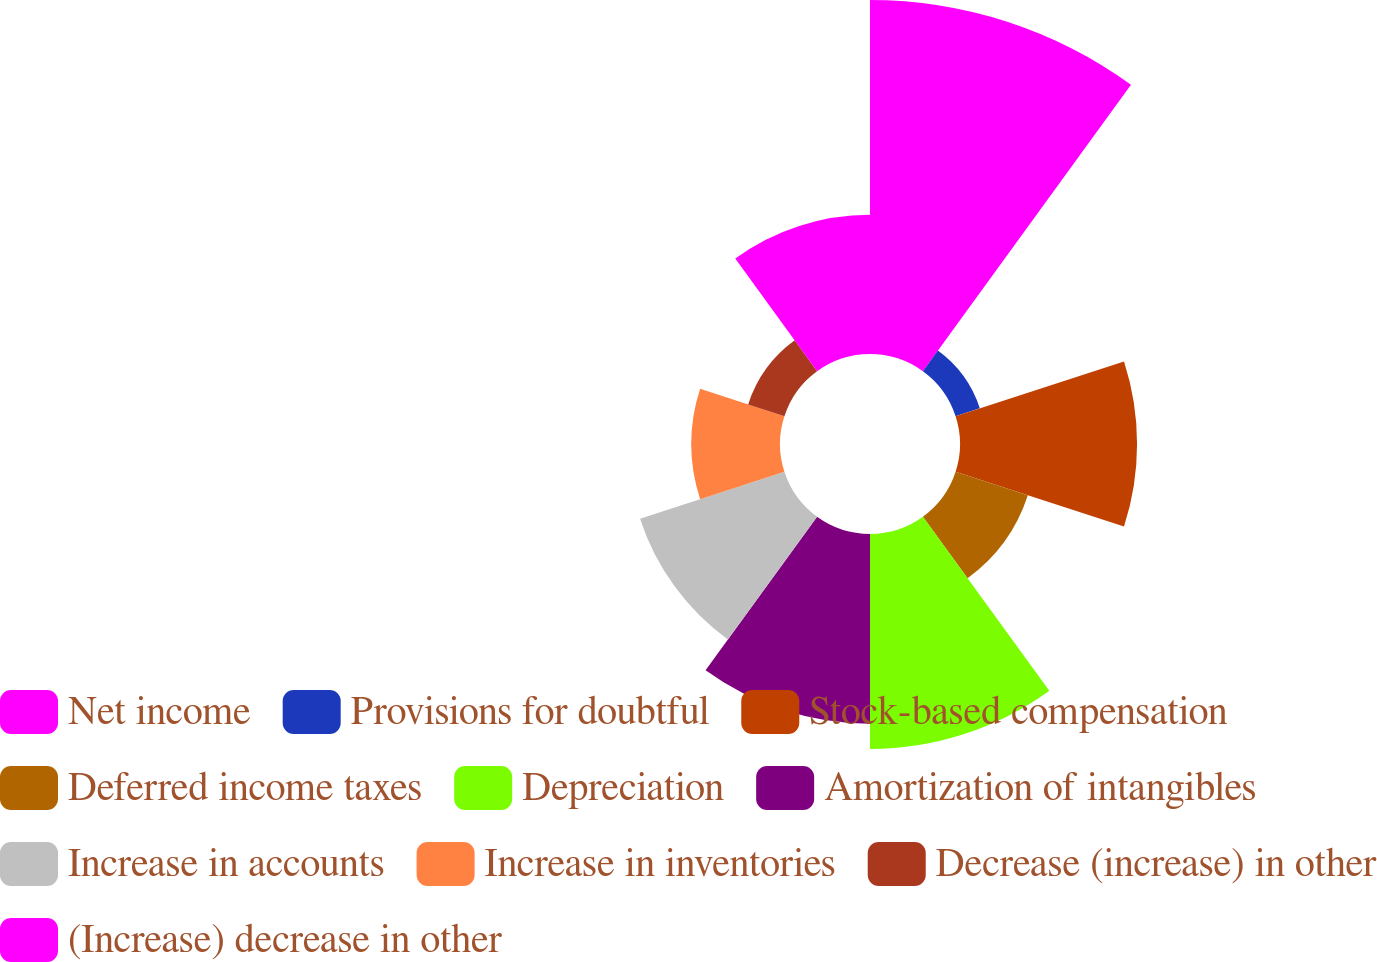<chart> <loc_0><loc_0><loc_500><loc_500><pie_chart><fcel>Net income<fcel>Provisions for doubtful<fcel>Stock-based compensation<fcel>Deferred income taxes<fcel>Depreciation<fcel>Amortization of intangibles<fcel>Increase in accounts<fcel>Increase in inventories<fcel>Decrease (increase) in other<fcel>(Increase) decrease in other<nl><fcel>24.33%<fcel>1.75%<fcel>12.17%<fcel>5.22%<fcel>14.78%<fcel>13.04%<fcel>10.43%<fcel>6.09%<fcel>2.62%<fcel>9.57%<nl></chart> 